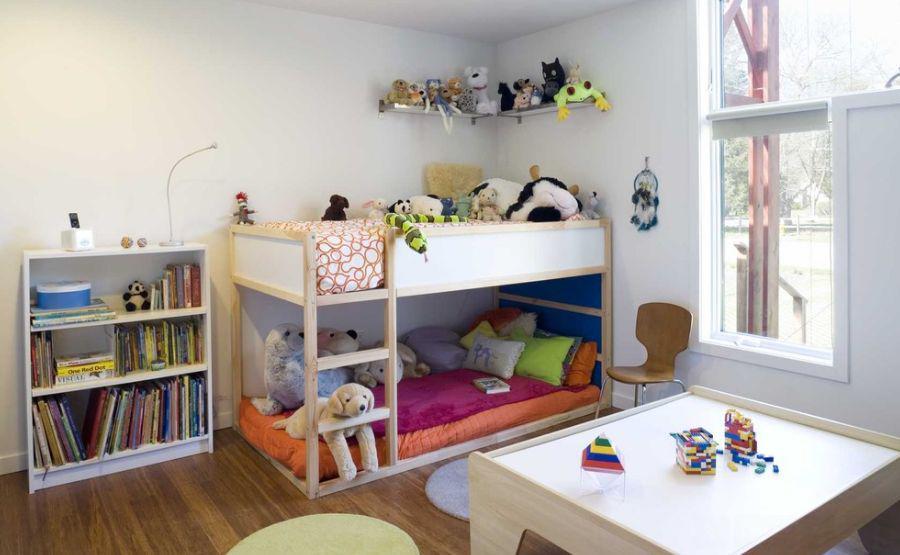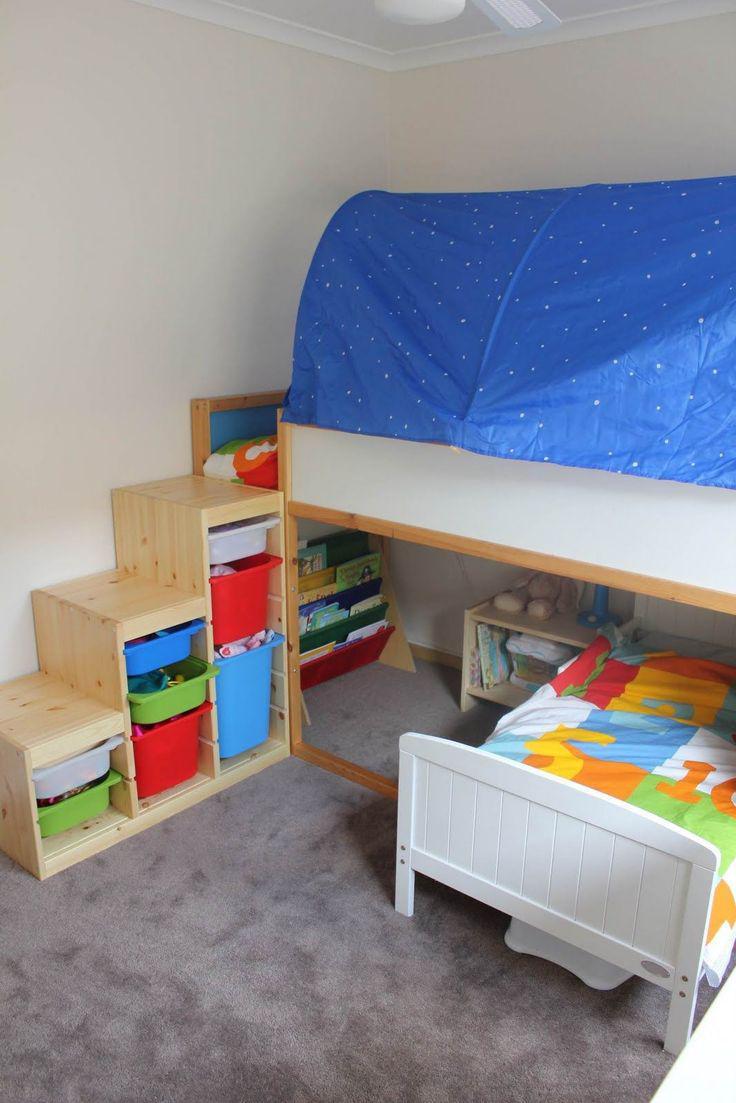The first image is the image on the left, the second image is the image on the right. Examine the images to the left and right. Is the description "None of the beds are bunk beds." accurate? Answer yes or no. No. The first image is the image on the left, the second image is the image on the right. Analyze the images presented: Is the assertion "AN image shows a bed with a patterned bedspread, flanked by black shelving joined by a top bridge." valid? Answer yes or no. No. 